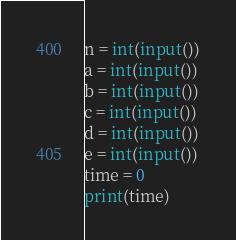<code> <loc_0><loc_0><loc_500><loc_500><_Python_>n = int(input())
a = int(input())
b = int(input())
c = int(input())
d = int(input())
e = int(input())
time = 0
print(time)</code> 